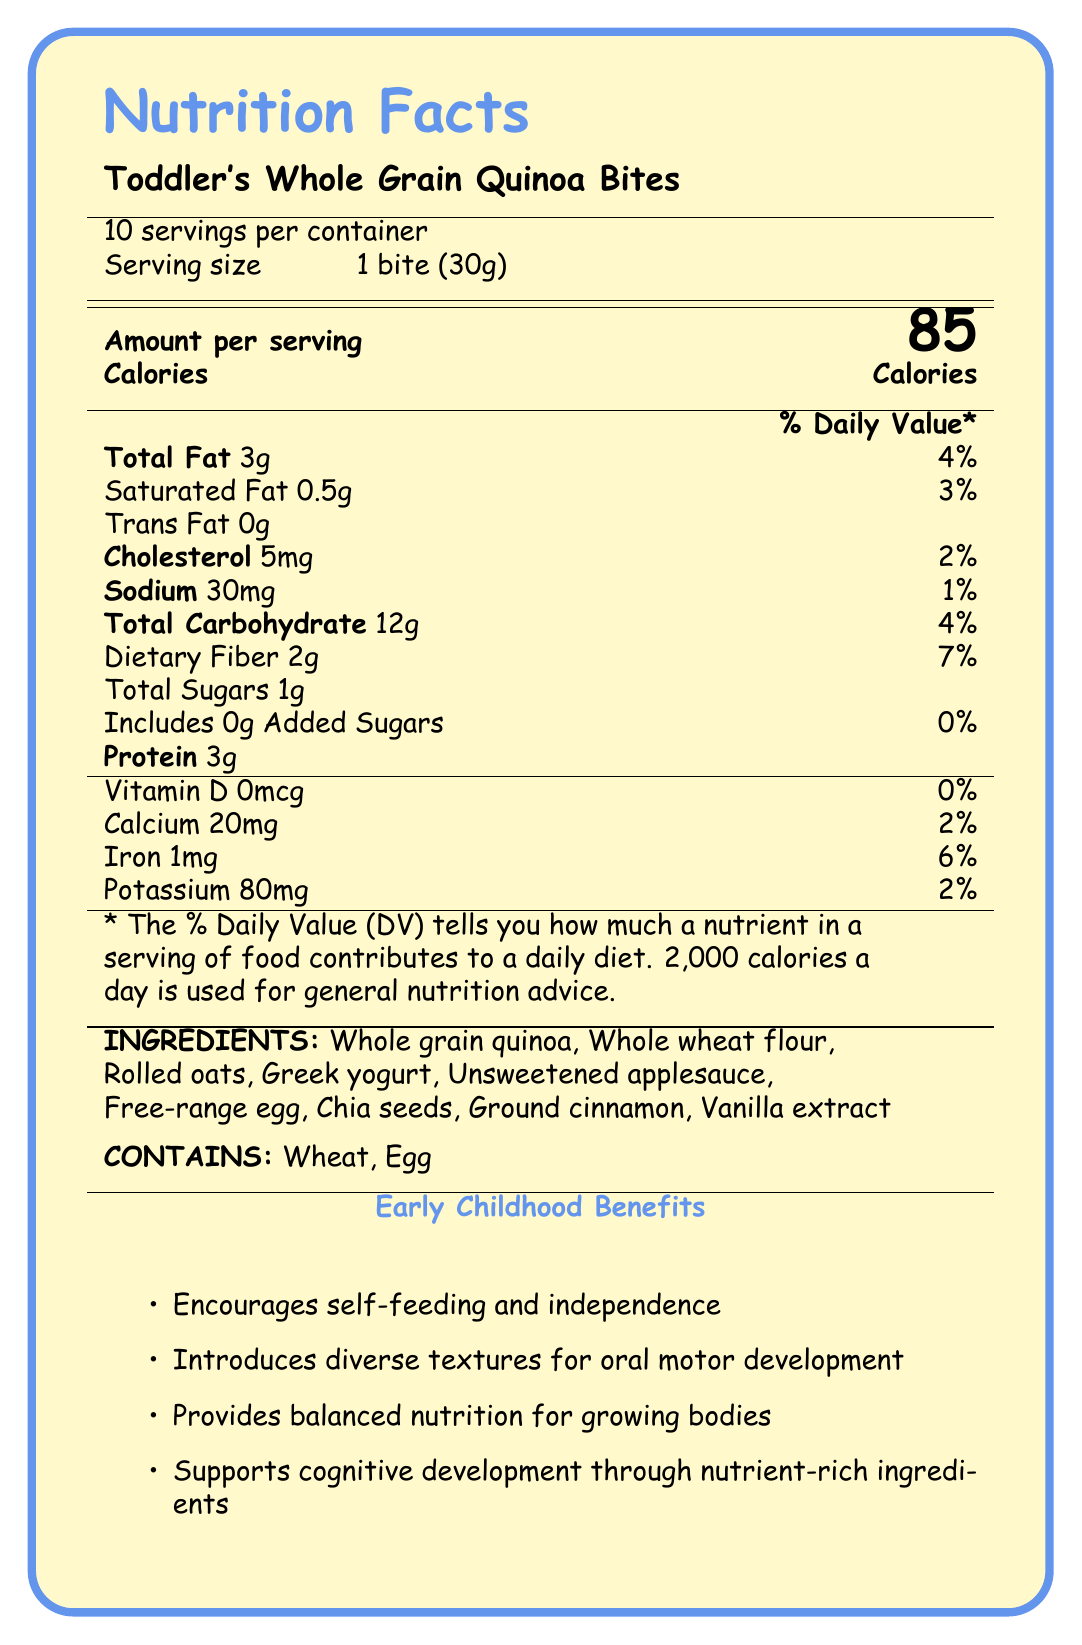what is the serving size of Toddler's Whole Grain Quinoa Bites? The serving size is clearly listed as "1 bite (30g)" in the document.
Answer: 1 bite (30g) how many calories are in one serving? The document states that there are 85 calories per serving.
Answer: 85 calories what nutrients are present in Toddler's Whole Grain Quinoa Bites? The document lists all of these nutrients under the "Amount per serving" and “% Daily Value” sections.
Answer: Total Fat, Saturated Fat, Trans Fat, Cholesterol, Sodium, Total Carbohydrate, Dietary Fiber, Total Sugars, Protein, Vitamin D, Calcium, Iron, Potassium how many grams of protein are in each bite? Protein content is specified as 3g per serving in the document.
Answer: 3g what are the main ingredients of the snack? The ingredients are listed towards the bottom of the document.
Answer: Whole grain quinoa, Whole wheat flour, Rolled oats, Greek yogurt, Unsweetened applesauce, Free-range egg, Chia seeds, Ground cinnamon, Vanilla extract what are the allergens present in this product? A. Dairy, Soy B. Wheat, Egg C. Nuts, Shellfish The document states "Contains: Wheat, Egg" in the allergens section.
Answer: B what is the dietary fiber content per serving? A. 1g B. 2g C. 3g D. 4g Dietary fiber content is listed as 2g per serving in the document.
Answer: B is there any added sugar in the snack? The document specifies "Includes 0g Added Sugars."
Answer: No does the snack encourage self-feeding and independence? One of the educational notes explicitly mentions that the snack "encourages self-feeding and independence."
Answer: Yes can we find the exact amount of Vitamin C in the snack from the document? The document does not mention the Vitamin C content.
Answer: Not enough information summarize the main idea of the document. The summary captures the overall purpose and contents of the document, highlighting both nutritional information and educational benefits.
Answer: The document provides nutritional information and educational benefits of Toddler's Whole Grain Quinoa Bites, a homemade snack designed to support healthy growth and development in toddlers. It includes nutrition facts, ingredient list, allergens, and preparation instructions while emphasizing benefits like encouraging self-feeding, balanced nutrition, and cognitive development. what is the cholesterol content percentage of daily value? The document lists cholesterol content as 5mg, which is 2% of the daily value.
Answer: 2% how many servings are there per container? The document states that there are 10 servings per container.
Answer: 10 what educational notes are provided for Toddler's Whole Grain Quinoa Bites? These are listed under the "educational notes" section of the document.
Answer: Designed to support healthy growth and development in toddlers, Rich in whole grains for sustained energy, Contains essential nutrients like iron and fiber, No added sugars or artificial preservatives, Supports fine motor skill development through self-feeding how much calcium is in each serving? A. 10mg B. 20mg C. 30mg D. 40mg The calcium content is specified as 20mg per serving in the document.
Answer: B are there any artificial preservatives in the product? One of the educational notes states that the product contains "No added sugars or artificial preservatives."
Answer: No for how long can the snack be stored at room temperature? A. Up to 1 day B. Up to 3 days C. Up to 1 week The preparation instructions state that the snack can be stored at room temperature for up to 3 days.
Answer: B 